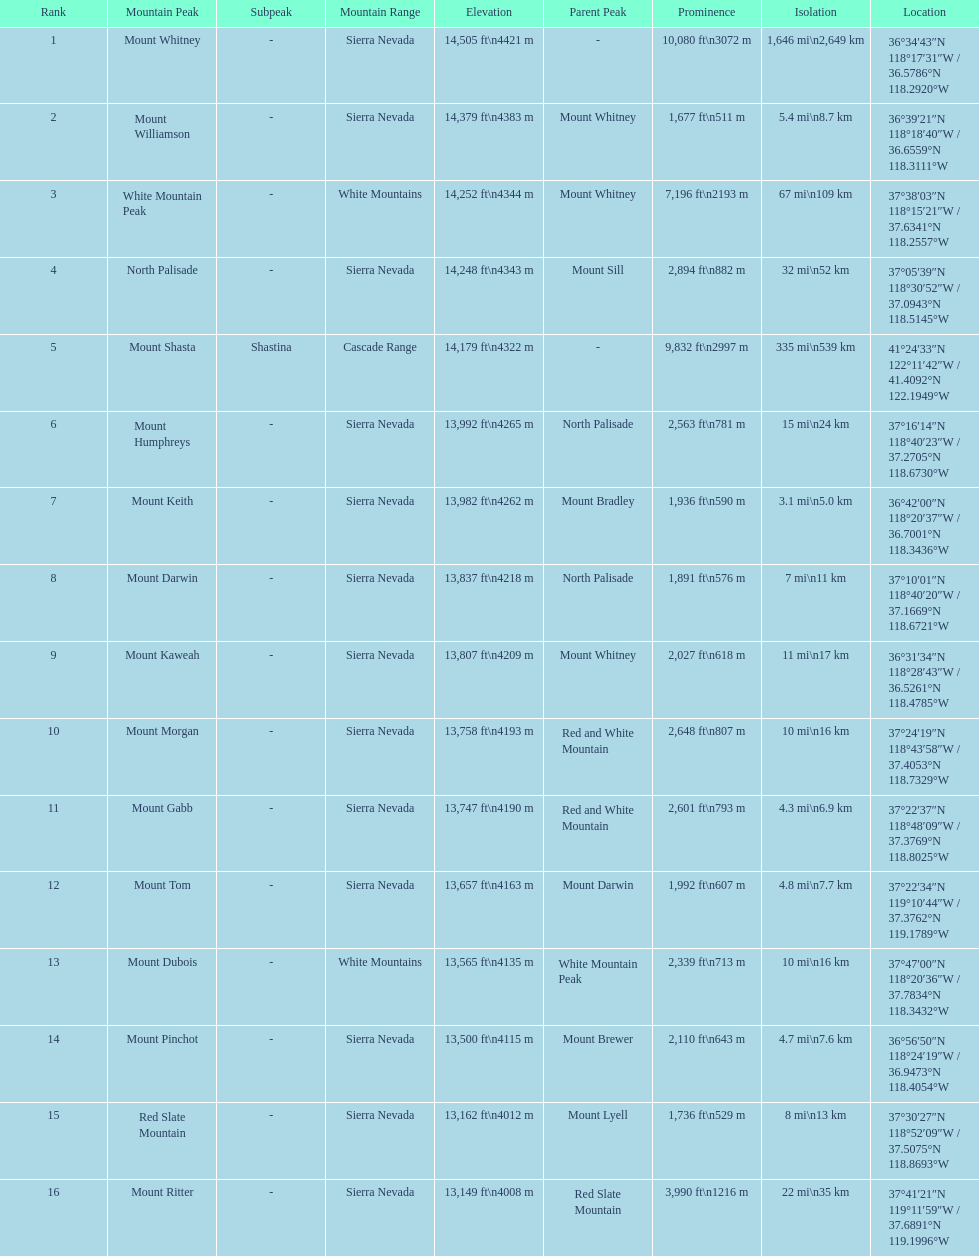How much taller is the mountain peak of mount williamson than that of mount keith? 397 ft. 